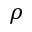Convert formula to latex. <formula><loc_0><loc_0><loc_500><loc_500>\rho</formula> 